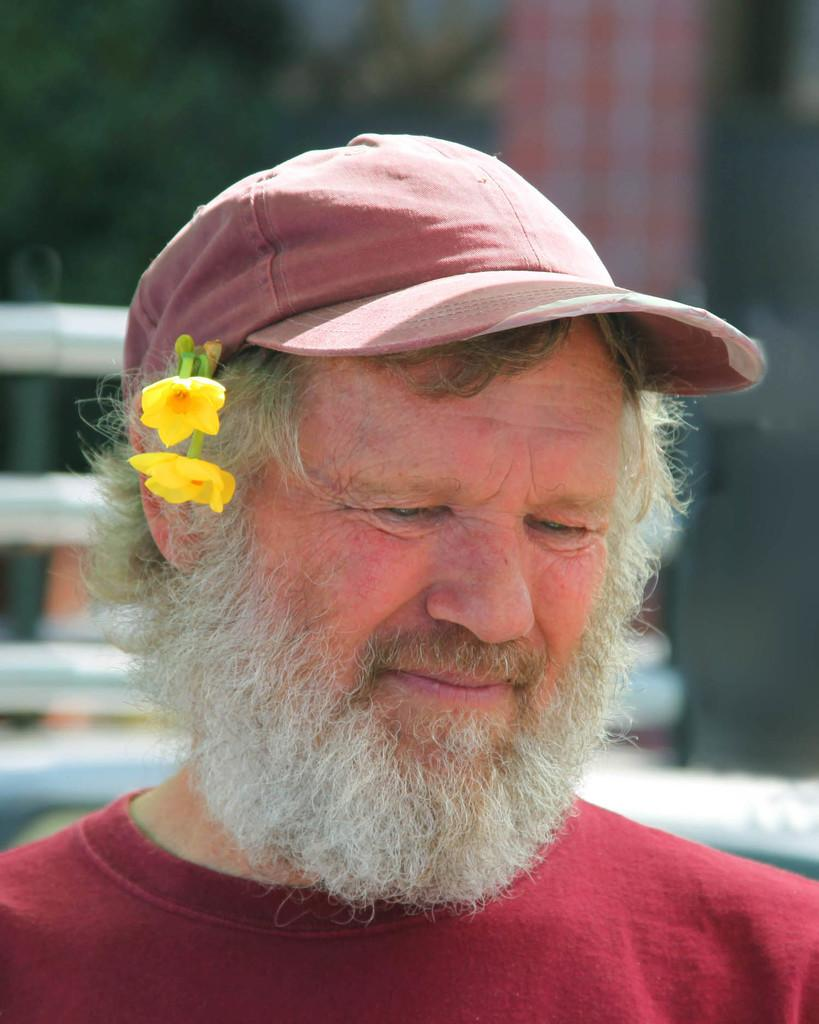Who is present in the image? There is a man in the image. What is the man wearing on his head? The man is wearing a cap. What is unique about the man's appearance? The man has flowers in his ears. What can be seen in the background of the image? There are rods and trees in the background of the image. What type of rings can be seen on the man's fingers in the image? There are no rings visible on the man's fingers in the image. What kind of roof is present above the man in the image? There is no roof present above the man in the image. 